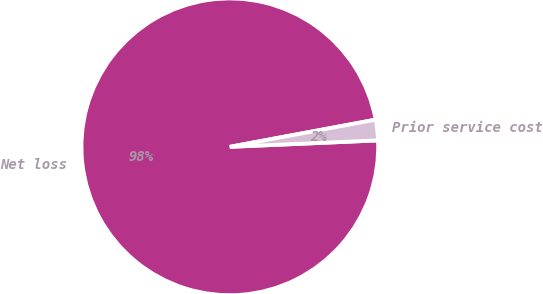Convert chart. <chart><loc_0><loc_0><loc_500><loc_500><pie_chart><fcel>Net loss<fcel>Prior service cost<nl><fcel>97.76%<fcel>2.24%<nl></chart> 